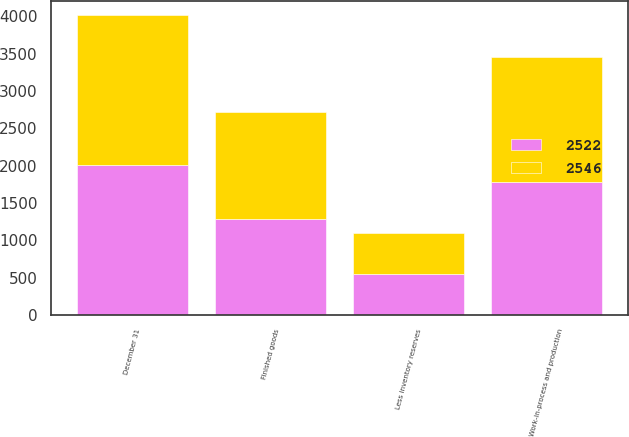Convert chart. <chart><loc_0><loc_0><loc_500><loc_500><stacked_bar_chart><ecel><fcel>December 31<fcel>Finished goods<fcel>Work-in-process and production<fcel>Less inventory reserves<nl><fcel>2522<fcel>2005<fcel>1287<fcel>1784<fcel>549<nl><fcel>2546<fcel>2004<fcel>1429<fcel>1665<fcel>548<nl></chart> 